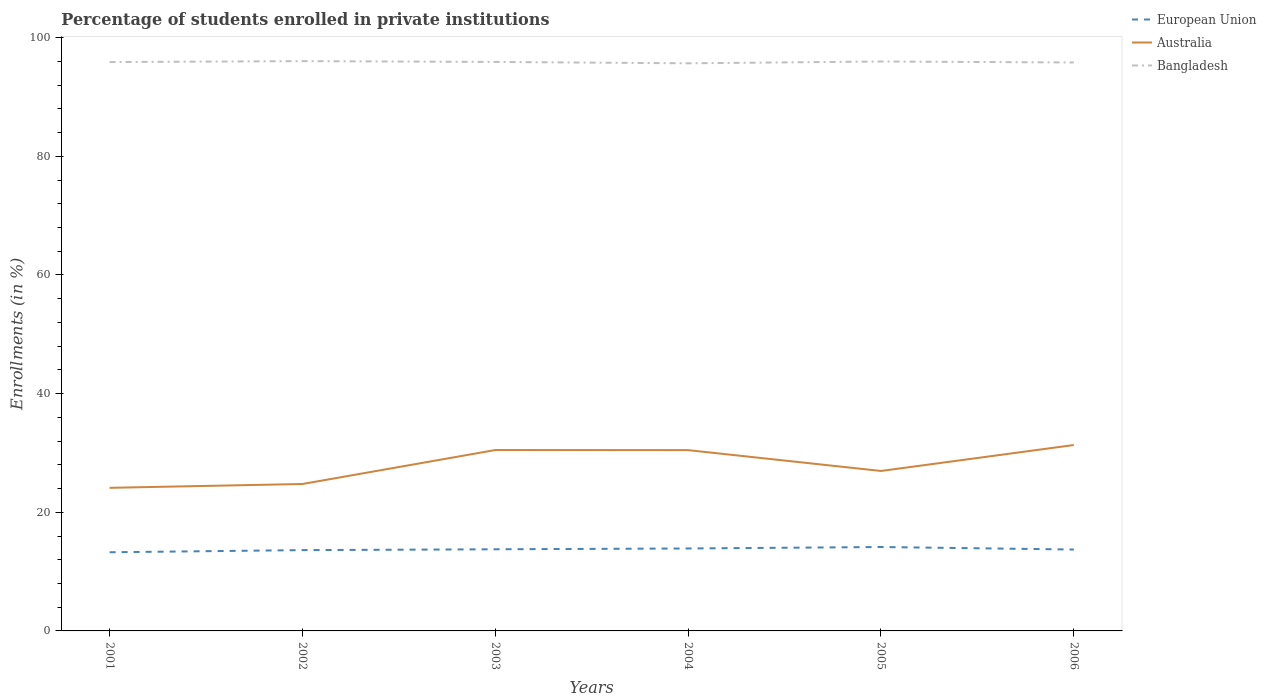How many different coloured lines are there?
Offer a very short reply. 3. Is the number of lines equal to the number of legend labels?
Offer a very short reply. Yes. Across all years, what is the maximum percentage of trained teachers in European Union?
Your answer should be compact. 13.26. What is the total percentage of trained teachers in European Union in the graph?
Provide a short and direct response. -0.89. What is the difference between the highest and the second highest percentage of trained teachers in Bangladesh?
Ensure brevity in your answer.  0.37. What is the difference between the highest and the lowest percentage of trained teachers in Bangladesh?
Your response must be concise. 4. How many years are there in the graph?
Offer a terse response. 6. What is the difference between two consecutive major ticks on the Y-axis?
Keep it short and to the point. 20. How many legend labels are there?
Your response must be concise. 3. What is the title of the graph?
Give a very brief answer. Percentage of students enrolled in private institutions. What is the label or title of the Y-axis?
Offer a very short reply. Enrollments (in %). What is the Enrollments (in %) of European Union in 2001?
Your answer should be very brief. 13.26. What is the Enrollments (in %) of Australia in 2001?
Your answer should be compact. 24.12. What is the Enrollments (in %) in Bangladesh in 2001?
Offer a terse response. 95.9. What is the Enrollments (in %) of European Union in 2002?
Your answer should be compact. 13.62. What is the Enrollments (in %) in Australia in 2002?
Offer a very short reply. 24.77. What is the Enrollments (in %) in Bangladesh in 2002?
Give a very brief answer. 96.05. What is the Enrollments (in %) in European Union in 2003?
Offer a terse response. 13.76. What is the Enrollments (in %) in Australia in 2003?
Provide a short and direct response. 30.49. What is the Enrollments (in %) of Bangladesh in 2003?
Your answer should be compact. 95.92. What is the Enrollments (in %) of European Union in 2004?
Provide a short and direct response. 13.9. What is the Enrollments (in %) of Australia in 2004?
Keep it short and to the point. 30.48. What is the Enrollments (in %) in Bangladesh in 2004?
Your answer should be very brief. 95.69. What is the Enrollments (in %) in European Union in 2005?
Ensure brevity in your answer.  14.15. What is the Enrollments (in %) in Australia in 2005?
Offer a very short reply. 26.97. What is the Enrollments (in %) in Bangladesh in 2005?
Provide a succinct answer. 95.99. What is the Enrollments (in %) of European Union in 2006?
Make the answer very short. 13.72. What is the Enrollments (in %) in Australia in 2006?
Ensure brevity in your answer.  31.34. What is the Enrollments (in %) of Bangladesh in 2006?
Offer a very short reply. 95.82. Across all years, what is the maximum Enrollments (in %) in European Union?
Your response must be concise. 14.15. Across all years, what is the maximum Enrollments (in %) of Australia?
Make the answer very short. 31.34. Across all years, what is the maximum Enrollments (in %) in Bangladesh?
Provide a short and direct response. 96.05. Across all years, what is the minimum Enrollments (in %) in European Union?
Your response must be concise. 13.26. Across all years, what is the minimum Enrollments (in %) of Australia?
Offer a very short reply. 24.12. Across all years, what is the minimum Enrollments (in %) in Bangladesh?
Offer a very short reply. 95.69. What is the total Enrollments (in %) of European Union in the graph?
Give a very brief answer. 82.41. What is the total Enrollments (in %) in Australia in the graph?
Provide a succinct answer. 168.16. What is the total Enrollments (in %) in Bangladesh in the graph?
Provide a succinct answer. 575.37. What is the difference between the Enrollments (in %) in European Union in 2001 and that in 2002?
Make the answer very short. -0.36. What is the difference between the Enrollments (in %) in Australia in 2001 and that in 2002?
Offer a very short reply. -0.65. What is the difference between the Enrollments (in %) in Bangladesh in 2001 and that in 2002?
Your response must be concise. -0.16. What is the difference between the Enrollments (in %) in European Union in 2001 and that in 2003?
Ensure brevity in your answer.  -0.5. What is the difference between the Enrollments (in %) in Australia in 2001 and that in 2003?
Provide a succinct answer. -6.37. What is the difference between the Enrollments (in %) of Bangladesh in 2001 and that in 2003?
Keep it short and to the point. -0.02. What is the difference between the Enrollments (in %) of European Union in 2001 and that in 2004?
Provide a short and direct response. -0.64. What is the difference between the Enrollments (in %) of Australia in 2001 and that in 2004?
Ensure brevity in your answer.  -6.35. What is the difference between the Enrollments (in %) of Bangladesh in 2001 and that in 2004?
Ensure brevity in your answer.  0.21. What is the difference between the Enrollments (in %) in European Union in 2001 and that in 2005?
Offer a very short reply. -0.89. What is the difference between the Enrollments (in %) in Australia in 2001 and that in 2005?
Give a very brief answer. -2.84. What is the difference between the Enrollments (in %) in Bangladesh in 2001 and that in 2005?
Offer a very short reply. -0.1. What is the difference between the Enrollments (in %) in European Union in 2001 and that in 2006?
Ensure brevity in your answer.  -0.46. What is the difference between the Enrollments (in %) in Australia in 2001 and that in 2006?
Your answer should be compact. -7.21. What is the difference between the Enrollments (in %) of Bangladesh in 2001 and that in 2006?
Give a very brief answer. 0.07. What is the difference between the Enrollments (in %) of European Union in 2002 and that in 2003?
Give a very brief answer. -0.14. What is the difference between the Enrollments (in %) in Australia in 2002 and that in 2003?
Keep it short and to the point. -5.72. What is the difference between the Enrollments (in %) in Bangladesh in 2002 and that in 2003?
Your answer should be very brief. 0.14. What is the difference between the Enrollments (in %) in European Union in 2002 and that in 2004?
Give a very brief answer. -0.28. What is the difference between the Enrollments (in %) of Australia in 2002 and that in 2004?
Provide a short and direct response. -5.71. What is the difference between the Enrollments (in %) in Bangladesh in 2002 and that in 2004?
Your answer should be very brief. 0.37. What is the difference between the Enrollments (in %) of European Union in 2002 and that in 2005?
Ensure brevity in your answer.  -0.52. What is the difference between the Enrollments (in %) in Australia in 2002 and that in 2005?
Your answer should be very brief. -2.2. What is the difference between the Enrollments (in %) of Bangladesh in 2002 and that in 2005?
Your response must be concise. 0.06. What is the difference between the Enrollments (in %) in European Union in 2002 and that in 2006?
Your answer should be compact. -0.1. What is the difference between the Enrollments (in %) of Australia in 2002 and that in 2006?
Offer a very short reply. -6.57. What is the difference between the Enrollments (in %) of Bangladesh in 2002 and that in 2006?
Provide a short and direct response. 0.23. What is the difference between the Enrollments (in %) of European Union in 2003 and that in 2004?
Keep it short and to the point. -0.14. What is the difference between the Enrollments (in %) in Australia in 2003 and that in 2004?
Provide a short and direct response. 0.02. What is the difference between the Enrollments (in %) in Bangladesh in 2003 and that in 2004?
Your response must be concise. 0.23. What is the difference between the Enrollments (in %) in European Union in 2003 and that in 2005?
Your answer should be very brief. -0.38. What is the difference between the Enrollments (in %) of Australia in 2003 and that in 2005?
Offer a very short reply. 3.53. What is the difference between the Enrollments (in %) in Bangladesh in 2003 and that in 2005?
Offer a very short reply. -0.08. What is the difference between the Enrollments (in %) in European Union in 2003 and that in 2006?
Offer a very short reply. 0.04. What is the difference between the Enrollments (in %) in Australia in 2003 and that in 2006?
Give a very brief answer. -0.84. What is the difference between the Enrollments (in %) of Bangladesh in 2003 and that in 2006?
Provide a succinct answer. 0.09. What is the difference between the Enrollments (in %) of European Union in 2004 and that in 2005?
Your response must be concise. -0.25. What is the difference between the Enrollments (in %) of Australia in 2004 and that in 2005?
Ensure brevity in your answer.  3.51. What is the difference between the Enrollments (in %) of Bangladesh in 2004 and that in 2005?
Offer a very short reply. -0.31. What is the difference between the Enrollments (in %) of European Union in 2004 and that in 2006?
Make the answer very short. 0.18. What is the difference between the Enrollments (in %) in Australia in 2004 and that in 2006?
Offer a very short reply. -0.86. What is the difference between the Enrollments (in %) of Bangladesh in 2004 and that in 2006?
Your answer should be very brief. -0.14. What is the difference between the Enrollments (in %) in European Union in 2005 and that in 2006?
Offer a terse response. 0.42. What is the difference between the Enrollments (in %) of Australia in 2005 and that in 2006?
Your response must be concise. -4.37. What is the difference between the Enrollments (in %) of Bangladesh in 2005 and that in 2006?
Offer a very short reply. 0.17. What is the difference between the Enrollments (in %) of European Union in 2001 and the Enrollments (in %) of Australia in 2002?
Keep it short and to the point. -11.51. What is the difference between the Enrollments (in %) of European Union in 2001 and the Enrollments (in %) of Bangladesh in 2002?
Offer a very short reply. -82.79. What is the difference between the Enrollments (in %) in Australia in 2001 and the Enrollments (in %) in Bangladesh in 2002?
Ensure brevity in your answer.  -71.93. What is the difference between the Enrollments (in %) in European Union in 2001 and the Enrollments (in %) in Australia in 2003?
Your answer should be compact. -17.23. What is the difference between the Enrollments (in %) in European Union in 2001 and the Enrollments (in %) in Bangladesh in 2003?
Offer a terse response. -82.66. What is the difference between the Enrollments (in %) of Australia in 2001 and the Enrollments (in %) of Bangladesh in 2003?
Your answer should be compact. -71.79. What is the difference between the Enrollments (in %) in European Union in 2001 and the Enrollments (in %) in Australia in 2004?
Provide a succinct answer. -17.22. What is the difference between the Enrollments (in %) in European Union in 2001 and the Enrollments (in %) in Bangladesh in 2004?
Give a very brief answer. -82.43. What is the difference between the Enrollments (in %) of Australia in 2001 and the Enrollments (in %) of Bangladesh in 2004?
Give a very brief answer. -71.56. What is the difference between the Enrollments (in %) in European Union in 2001 and the Enrollments (in %) in Australia in 2005?
Give a very brief answer. -13.71. What is the difference between the Enrollments (in %) in European Union in 2001 and the Enrollments (in %) in Bangladesh in 2005?
Your response must be concise. -82.73. What is the difference between the Enrollments (in %) in Australia in 2001 and the Enrollments (in %) in Bangladesh in 2005?
Keep it short and to the point. -71.87. What is the difference between the Enrollments (in %) of European Union in 2001 and the Enrollments (in %) of Australia in 2006?
Keep it short and to the point. -18.08. What is the difference between the Enrollments (in %) in European Union in 2001 and the Enrollments (in %) in Bangladesh in 2006?
Your response must be concise. -82.57. What is the difference between the Enrollments (in %) in Australia in 2001 and the Enrollments (in %) in Bangladesh in 2006?
Ensure brevity in your answer.  -71.7. What is the difference between the Enrollments (in %) of European Union in 2002 and the Enrollments (in %) of Australia in 2003?
Make the answer very short. -16.87. What is the difference between the Enrollments (in %) in European Union in 2002 and the Enrollments (in %) in Bangladesh in 2003?
Make the answer very short. -82.29. What is the difference between the Enrollments (in %) of Australia in 2002 and the Enrollments (in %) of Bangladesh in 2003?
Offer a terse response. -71.15. What is the difference between the Enrollments (in %) in European Union in 2002 and the Enrollments (in %) in Australia in 2004?
Offer a very short reply. -16.86. What is the difference between the Enrollments (in %) in European Union in 2002 and the Enrollments (in %) in Bangladesh in 2004?
Offer a very short reply. -82.07. What is the difference between the Enrollments (in %) in Australia in 2002 and the Enrollments (in %) in Bangladesh in 2004?
Your answer should be very brief. -70.92. What is the difference between the Enrollments (in %) of European Union in 2002 and the Enrollments (in %) of Australia in 2005?
Offer a terse response. -13.34. What is the difference between the Enrollments (in %) in European Union in 2002 and the Enrollments (in %) in Bangladesh in 2005?
Your response must be concise. -82.37. What is the difference between the Enrollments (in %) in Australia in 2002 and the Enrollments (in %) in Bangladesh in 2005?
Your response must be concise. -71.22. What is the difference between the Enrollments (in %) in European Union in 2002 and the Enrollments (in %) in Australia in 2006?
Provide a short and direct response. -17.72. What is the difference between the Enrollments (in %) of European Union in 2002 and the Enrollments (in %) of Bangladesh in 2006?
Your answer should be very brief. -82.2. What is the difference between the Enrollments (in %) of Australia in 2002 and the Enrollments (in %) of Bangladesh in 2006?
Keep it short and to the point. -71.06. What is the difference between the Enrollments (in %) of European Union in 2003 and the Enrollments (in %) of Australia in 2004?
Your answer should be compact. -16.72. What is the difference between the Enrollments (in %) in European Union in 2003 and the Enrollments (in %) in Bangladesh in 2004?
Your answer should be compact. -81.92. What is the difference between the Enrollments (in %) in Australia in 2003 and the Enrollments (in %) in Bangladesh in 2004?
Make the answer very short. -65.19. What is the difference between the Enrollments (in %) in European Union in 2003 and the Enrollments (in %) in Australia in 2005?
Provide a short and direct response. -13.2. What is the difference between the Enrollments (in %) in European Union in 2003 and the Enrollments (in %) in Bangladesh in 2005?
Offer a very short reply. -82.23. What is the difference between the Enrollments (in %) of Australia in 2003 and the Enrollments (in %) of Bangladesh in 2005?
Give a very brief answer. -65.5. What is the difference between the Enrollments (in %) of European Union in 2003 and the Enrollments (in %) of Australia in 2006?
Your response must be concise. -17.57. What is the difference between the Enrollments (in %) in European Union in 2003 and the Enrollments (in %) in Bangladesh in 2006?
Provide a short and direct response. -82.06. What is the difference between the Enrollments (in %) of Australia in 2003 and the Enrollments (in %) of Bangladesh in 2006?
Ensure brevity in your answer.  -65.33. What is the difference between the Enrollments (in %) of European Union in 2004 and the Enrollments (in %) of Australia in 2005?
Your response must be concise. -13.07. What is the difference between the Enrollments (in %) of European Union in 2004 and the Enrollments (in %) of Bangladesh in 2005?
Offer a terse response. -82.09. What is the difference between the Enrollments (in %) in Australia in 2004 and the Enrollments (in %) in Bangladesh in 2005?
Provide a succinct answer. -65.51. What is the difference between the Enrollments (in %) of European Union in 2004 and the Enrollments (in %) of Australia in 2006?
Your answer should be very brief. -17.44. What is the difference between the Enrollments (in %) in European Union in 2004 and the Enrollments (in %) in Bangladesh in 2006?
Keep it short and to the point. -81.93. What is the difference between the Enrollments (in %) of Australia in 2004 and the Enrollments (in %) of Bangladesh in 2006?
Your response must be concise. -65.35. What is the difference between the Enrollments (in %) of European Union in 2005 and the Enrollments (in %) of Australia in 2006?
Ensure brevity in your answer.  -17.19. What is the difference between the Enrollments (in %) of European Union in 2005 and the Enrollments (in %) of Bangladesh in 2006?
Give a very brief answer. -81.68. What is the difference between the Enrollments (in %) of Australia in 2005 and the Enrollments (in %) of Bangladesh in 2006?
Provide a short and direct response. -68.86. What is the average Enrollments (in %) in European Union per year?
Offer a terse response. 13.73. What is the average Enrollments (in %) of Australia per year?
Your answer should be very brief. 28.03. What is the average Enrollments (in %) of Bangladesh per year?
Offer a very short reply. 95.89. In the year 2001, what is the difference between the Enrollments (in %) in European Union and Enrollments (in %) in Australia?
Your answer should be very brief. -10.86. In the year 2001, what is the difference between the Enrollments (in %) of European Union and Enrollments (in %) of Bangladesh?
Offer a terse response. -82.64. In the year 2001, what is the difference between the Enrollments (in %) of Australia and Enrollments (in %) of Bangladesh?
Give a very brief answer. -71.77. In the year 2002, what is the difference between the Enrollments (in %) in European Union and Enrollments (in %) in Australia?
Your answer should be very brief. -11.15. In the year 2002, what is the difference between the Enrollments (in %) in European Union and Enrollments (in %) in Bangladesh?
Offer a very short reply. -82.43. In the year 2002, what is the difference between the Enrollments (in %) in Australia and Enrollments (in %) in Bangladesh?
Give a very brief answer. -71.28. In the year 2003, what is the difference between the Enrollments (in %) of European Union and Enrollments (in %) of Australia?
Your response must be concise. -16.73. In the year 2003, what is the difference between the Enrollments (in %) in European Union and Enrollments (in %) in Bangladesh?
Give a very brief answer. -82.15. In the year 2003, what is the difference between the Enrollments (in %) of Australia and Enrollments (in %) of Bangladesh?
Keep it short and to the point. -65.42. In the year 2004, what is the difference between the Enrollments (in %) of European Union and Enrollments (in %) of Australia?
Your response must be concise. -16.58. In the year 2004, what is the difference between the Enrollments (in %) of European Union and Enrollments (in %) of Bangladesh?
Keep it short and to the point. -81.79. In the year 2004, what is the difference between the Enrollments (in %) in Australia and Enrollments (in %) in Bangladesh?
Ensure brevity in your answer.  -65.21. In the year 2005, what is the difference between the Enrollments (in %) in European Union and Enrollments (in %) in Australia?
Offer a terse response. -12.82. In the year 2005, what is the difference between the Enrollments (in %) of European Union and Enrollments (in %) of Bangladesh?
Ensure brevity in your answer.  -81.85. In the year 2005, what is the difference between the Enrollments (in %) of Australia and Enrollments (in %) of Bangladesh?
Give a very brief answer. -69.03. In the year 2006, what is the difference between the Enrollments (in %) of European Union and Enrollments (in %) of Australia?
Keep it short and to the point. -17.62. In the year 2006, what is the difference between the Enrollments (in %) in European Union and Enrollments (in %) in Bangladesh?
Offer a very short reply. -82.1. In the year 2006, what is the difference between the Enrollments (in %) of Australia and Enrollments (in %) of Bangladesh?
Provide a succinct answer. -64.49. What is the ratio of the Enrollments (in %) in European Union in 2001 to that in 2002?
Your answer should be compact. 0.97. What is the ratio of the Enrollments (in %) of Australia in 2001 to that in 2002?
Your response must be concise. 0.97. What is the ratio of the Enrollments (in %) of Bangladesh in 2001 to that in 2002?
Offer a very short reply. 1. What is the ratio of the Enrollments (in %) of European Union in 2001 to that in 2003?
Keep it short and to the point. 0.96. What is the ratio of the Enrollments (in %) in Australia in 2001 to that in 2003?
Your response must be concise. 0.79. What is the ratio of the Enrollments (in %) in European Union in 2001 to that in 2004?
Give a very brief answer. 0.95. What is the ratio of the Enrollments (in %) in Australia in 2001 to that in 2004?
Ensure brevity in your answer.  0.79. What is the ratio of the Enrollments (in %) of Bangladesh in 2001 to that in 2004?
Offer a terse response. 1. What is the ratio of the Enrollments (in %) of European Union in 2001 to that in 2005?
Your answer should be very brief. 0.94. What is the ratio of the Enrollments (in %) in Australia in 2001 to that in 2005?
Ensure brevity in your answer.  0.89. What is the ratio of the Enrollments (in %) in Bangladesh in 2001 to that in 2005?
Your response must be concise. 1. What is the ratio of the Enrollments (in %) in European Union in 2001 to that in 2006?
Ensure brevity in your answer.  0.97. What is the ratio of the Enrollments (in %) in Australia in 2001 to that in 2006?
Provide a succinct answer. 0.77. What is the ratio of the Enrollments (in %) of Bangladesh in 2001 to that in 2006?
Offer a terse response. 1. What is the ratio of the Enrollments (in %) of Australia in 2002 to that in 2003?
Provide a short and direct response. 0.81. What is the ratio of the Enrollments (in %) in Bangladesh in 2002 to that in 2003?
Your answer should be compact. 1. What is the ratio of the Enrollments (in %) of European Union in 2002 to that in 2004?
Offer a very short reply. 0.98. What is the ratio of the Enrollments (in %) of Australia in 2002 to that in 2004?
Make the answer very short. 0.81. What is the ratio of the Enrollments (in %) in Bangladesh in 2002 to that in 2004?
Give a very brief answer. 1. What is the ratio of the Enrollments (in %) of European Union in 2002 to that in 2005?
Your answer should be compact. 0.96. What is the ratio of the Enrollments (in %) of Australia in 2002 to that in 2005?
Your answer should be compact. 0.92. What is the ratio of the Enrollments (in %) of European Union in 2002 to that in 2006?
Offer a very short reply. 0.99. What is the ratio of the Enrollments (in %) in Australia in 2002 to that in 2006?
Ensure brevity in your answer.  0.79. What is the ratio of the Enrollments (in %) of Bangladesh in 2002 to that in 2006?
Keep it short and to the point. 1. What is the ratio of the Enrollments (in %) of European Union in 2003 to that in 2004?
Keep it short and to the point. 0.99. What is the ratio of the Enrollments (in %) of Australia in 2003 to that in 2004?
Give a very brief answer. 1. What is the ratio of the Enrollments (in %) in Bangladesh in 2003 to that in 2004?
Make the answer very short. 1. What is the ratio of the Enrollments (in %) of European Union in 2003 to that in 2005?
Keep it short and to the point. 0.97. What is the ratio of the Enrollments (in %) in Australia in 2003 to that in 2005?
Your response must be concise. 1.13. What is the ratio of the Enrollments (in %) in Australia in 2003 to that in 2006?
Ensure brevity in your answer.  0.97. What is the ratio of the Enrollments (in %) in European Union in 2004 to that in 2005?
Ensure brevity in your answer.  0.98. What is the ratio of the Enrollments (in %) in Australia in 2004 to that in 2005?
Provide a succinct answer. 1.13. What is the ratio of the Enrollments (in %) in Bangladesh in 2004 to that in 2005?
Ensure brevity in your answer.  1. What is the ratio of the Enrollments (in %) of European Union in 2004 to that in 2006?
Give a very brief answer. 1.01. What is the ratio of the Enrollments (in %) in Australia in 2004 to that in 2006?
Provide a succinct answer. 0.97. What is the ratio of the Enrollments (in %) in European Union in 2005 to that in 2006?
Offer a very short reply. 1.03. What is the ratio of the Enrollments (in %) in Australia in 2005 to that in 2006?
Your answer should be compact. 0.86. What is the difference between the highest and the second highest Enrollments (in %) in European Union?
Ensure brevity in your answer.  0.25. What is the difference between the highest and the second highest Enrollments (in %) in Australia?
Provide a short and direct response. 0.84. What is the difference between the highest and the second highest Enrollments (in %) in Bangladesh?
Provide a short and direct response. 0.06. What is the difference between the highest and the lowest Enrollments (in %) of European Union?
Make the answer very short. 0.89. What is the difference between the highest and the lowest Enrollments (in %) of Australia?
Your response must be concise. 7.21. What is the difference between the highest and the lowest Enrollments (in %) of Bangladesh?
Your answer should be very brief. 0.37. 